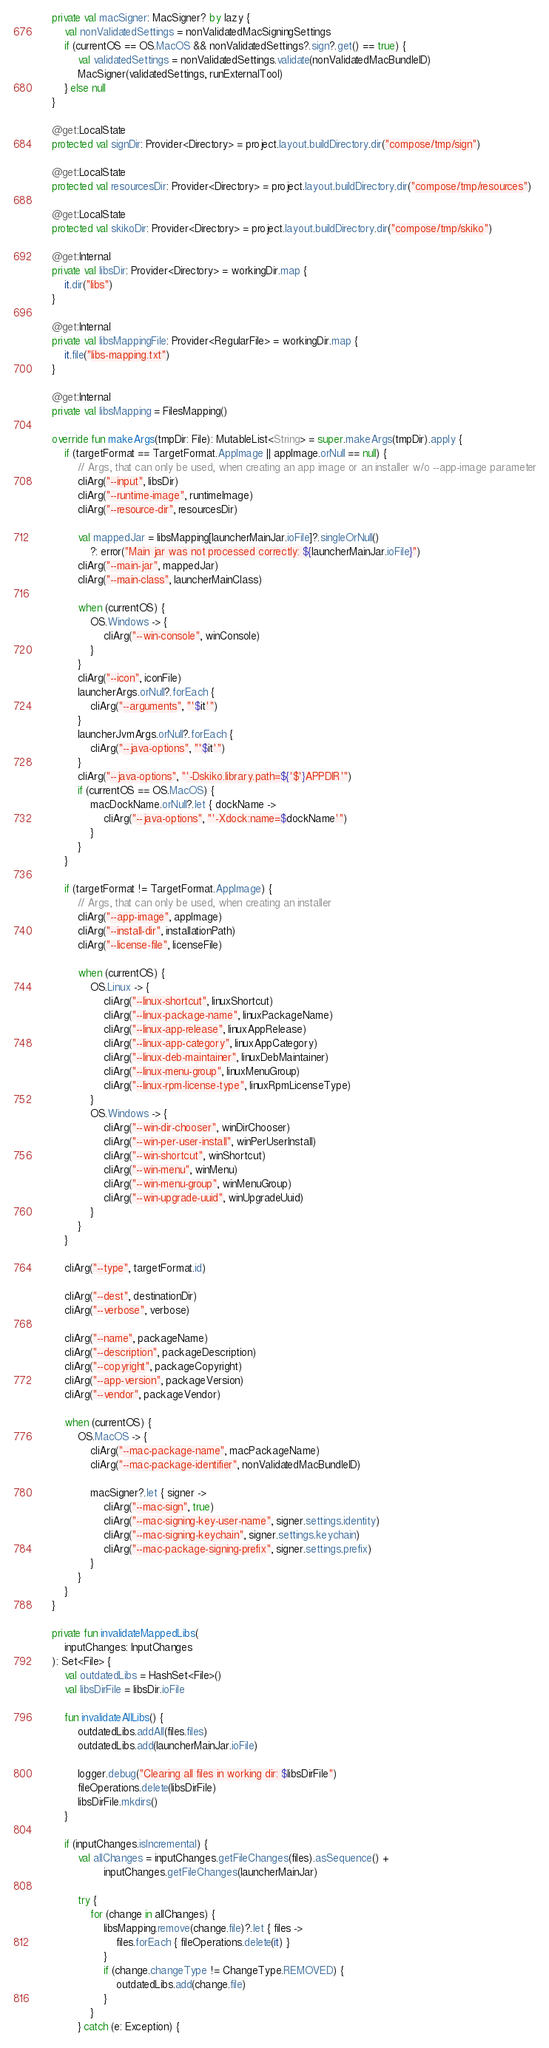Convert code to text. <code><loc_0><loc_0><loc_500><loc_500><_Kotlin_>
    private val macSigner: MacSigner? by lazy {
        val nonValidatedSettings = nonValidatedMacSigningSettings
        if (currentOS == OS.MacOS && nonValidatedSettings?.sign?.get() == true) {
            val validatedSettings = nonValidatedSettings.validate(nonValidatedMacBundleID)
            MacSigner(validatedSettings, runExternalTool)
        } else null
    }

    @get:LocalState
    protected val signDir: Provider<Directory> = project.layout.buildDirectory.dir("compose/tmp/sign")

    @get:LocalState
    protected val resourcesDir: Provider<Directory> = project.layout.buildDirectory.dir("compose/tmp/resources")

    @get:LocalState
    protected val skikoDir: Provider<Directory> = project.layout.buildDirectory.dir("compose/tmp/skiko")

    @get:Internal
    private val libsDir: Provider<Directory> = workingDir.map {
        it.dir("libs")
    }

    @get:Internal
    private val libsMappingFile: Provider<RegularFile> = workingDir.map {
        it.file("libs-mapping.txt")
    }

    @get:Internal
    private val libsMapping = FilesMapping()

    override fun makeArgs(tmpDir: File): MutableList<String> = super.makeArgs(tmpDir).apply {
        if (targetFormat == TargetFormat.AppImage || appImage.orNull == null) {
            // Args, that can only be used, when creating an app image or an installer w/o --app-image parameter
            cliArg("--input", libsDir)
            cliArg("--runtime-image", runtimeImage)
            cliArg("--resource-dir", resourcesDir)

            val mappedJar = libsMapping[launcherMainJar.ioFile]?.singleOrNull()
                ?: error("Main jar was not processed correctly: ${launcherMainJar.ioFile}")
            cliArg("--main-jar", mappedJar)
            cliArg("--main-class", launcherMainClass)

            when (currentOS) {
                OS.Windows -> {
                    cliArg("--win-console", winConsole)
                }
            }
            cliArg("--icon", iconFile)
            launcherArgs.orNull?.forEach {
                cliArg("--arguments", "'$it'")
            }
            launcherJvmArgs.orNull?.forEach {
                cliArg("--java-options", "'$it'")
            }
            cliArg("--java-options", "'-Dskiko.library.path=${'$'}APPDIR'")
            if (currentOS == OS.MacOS) {
                macDockName.orNull?.let { dockName ->
                    cliArg("--java-options", "'-Xdock:name=$dockName'")
                }
            }
        }

        if (targetFormat != TargetFormat.AppImage) {
            // Args, that can only be used, when creating an installer
            cliArg("--app-image", appImage)
            cliArg("--install-dir", installationPath)
            cliArg("--license-file", licenseFile)

            when (currentOS) {
                OS.Linux -> {
                    cliArg("--linux-shortcut", linuxShortcut)
                    cliArg("--linux-package-name", linuxPackageName)
                    cliArg("--linux-app-release", linuxAppRelease)
                    cliArg("--linux-app-category", linuxAppCategory)
                    cliArg("--linux-deb-maintainer", linuxDebMaintainer)
                    cliArg("--linux-menu-group", linuxMenuGroup)
                    cliArg("--linux-rpm-license-type", linuxRpmLicenseType)
                }
                OS.Windows -> {
                    cliArg("--win-dir-chooser", winDirChooser)
                    cliArg("--win-per-user-install", winPerUserInstall)
                    cliArg("--win-shortcut", winShortcut)
                    cliArg("--win-menu", winMenu)
                    cliArg("--win-menu-group", winMenuGroup)
                    cliArg("--win-upgrade-uuid", winUpgradeUuid)
                }
            }
        }

        cliArg("--type", targetFormat.id)

        cliArg("--dest", destinationDir)
        cliArg("--verbose", verbose)

        cliArg("--name", packageName)
        cliArg("--description", packageDescription)
        cliArg("--copyright", packageCopyright)
        cliArg("--app-version", packageVersion)
        cliArg("--vendor", packageVendor)

        when (currentOS) {
            OS.MacOS -> {
                cliArg("--mac-package-name", macPackageName)
                cliArg("--mac-package-identifier", nonValidatedMacBundleID)

                macSigner?.let { signer ->
                    cliArg("--mac-sign", true)
                    cliArg("--mac-signing-key-user-name", signer.settings.identity)
                    cliArg("--mac-signing-keychain", signer.settings.keychain)
                    cliArg("--mac-package-signing-prefix", signer.settings.prefix)
                }
            }
        }
    }

    private fun invalidateMappedLibs(
        inputChanges: InputChanges
    ): Set<File> {
        val outdatedLibs = HashSet<File>()
        val libsDirFile = libsDir.ioFile

        fun invalidateAllLibs() {
            outdatedLibs.addAll(files.files)
            outdatedLibs.add(launcherMainJar.ioFile)

            logger.debug("Clearing all files in working dir: $libsDirFile")
            fileOperations.delete(libsDirFile)
            libsDirFile.mkdirs()
        }

        if (inputChanges.isIncremental) {
            val allChanges = inputChanges.getFileChanges(files).asSequence() +
                    inputChanges.getFileChanges(launcherMainJar)

            try {
                for (change in allChanges) {
                    libsMapping.remove(change.file)?.let { files ->
                        files.forEach { fileOperations.delete(it) }
                    }
                    if (change.changeType != ChangeType.REMOVED) {
                        outdatedLibs.add(change.file)
                    }
                }
            } catch (e: Exception) {</code> 